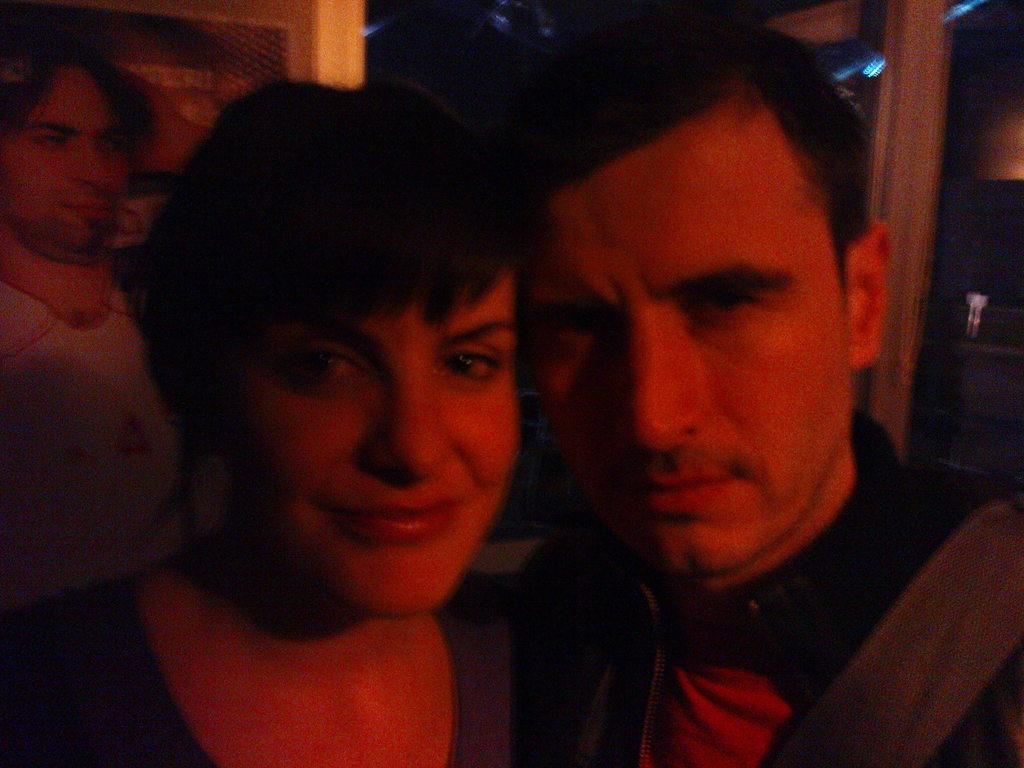Who or what can be seen in the image? There are people in the image. Can you describe the background of the image? There are objects in the background of the image. What type of star can be seen in the image? There is no star present in the image. What breed of dog is visible in the image? There is no dog present in the image. 